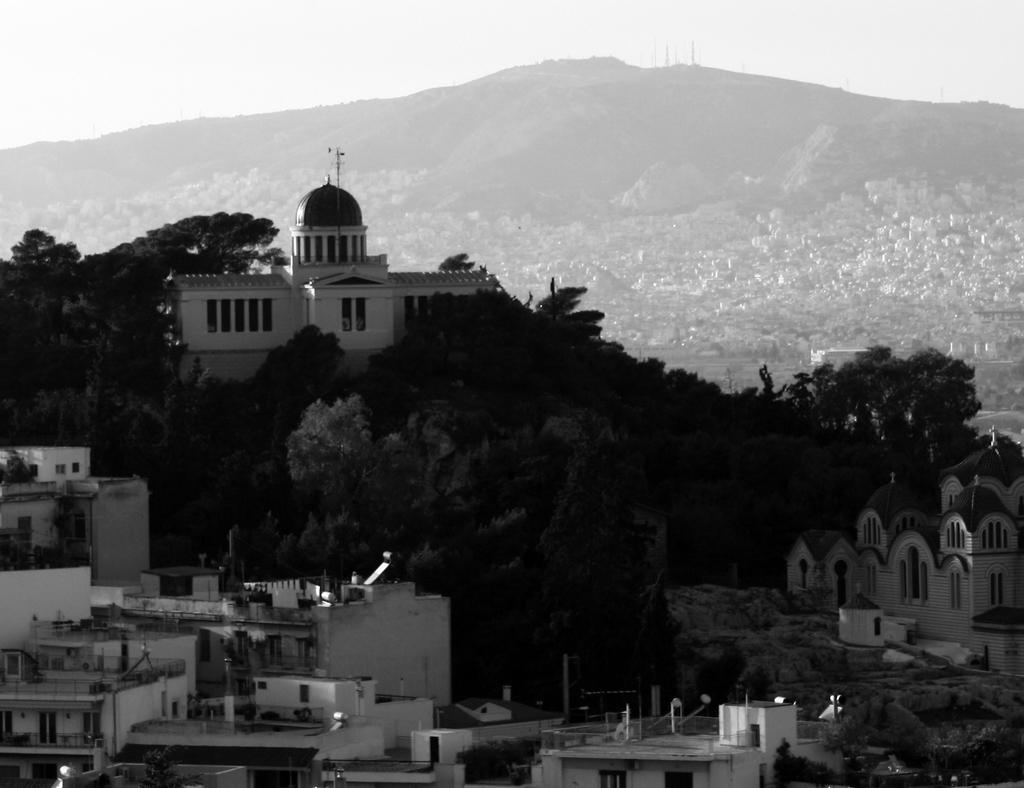What is located in the center of the image? There are buildings in the center of the image. What type of vegetation can be seen in the image? There are trees in the image. What natural feature is visible in the background of the image? There are mountains in the background of the image. How would you describe the sky in the image? The sky is cloudy in the image. What type of comb is being used to style the trees in the image? There is no comb present in the image, and the trees are not being styled. Where is the vacation destination shown in the image? The image does not depict a vacation destination; it features buildings, trees, mountains, and a cloudy sky. 